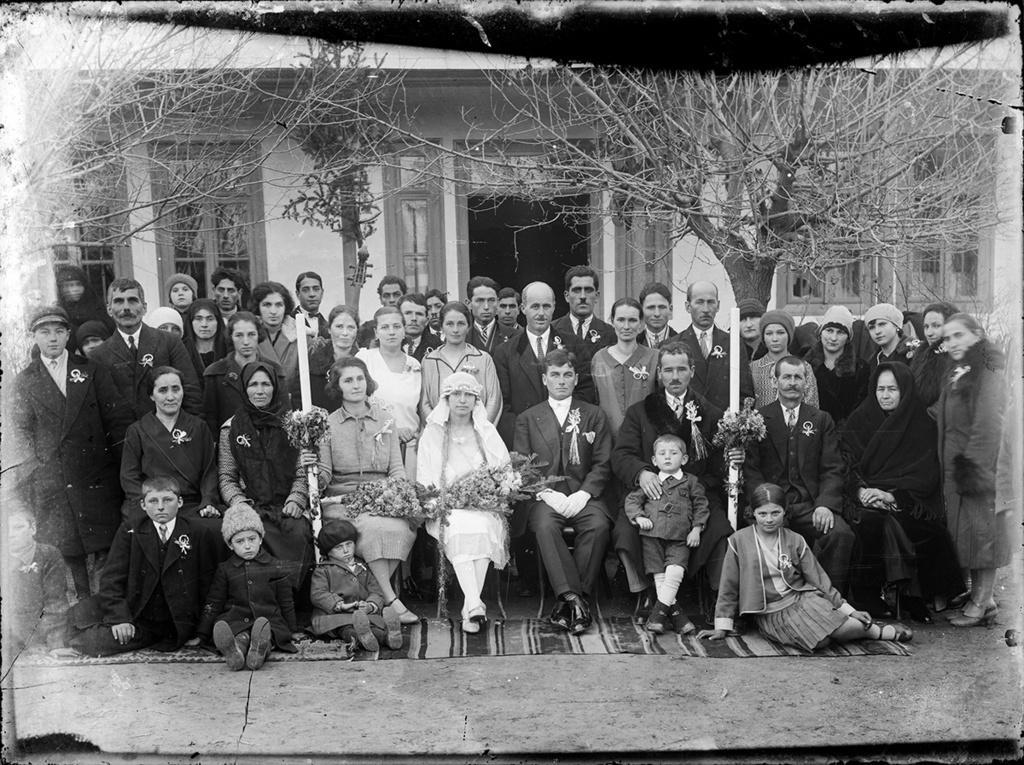Please provide a concise description of this image. This is a black and white image. In the center of the image there are people sitting on chairs. Behind them there are people standing. In the background of the image there is house,trees,doors. At the bottom of the image there is floor. 